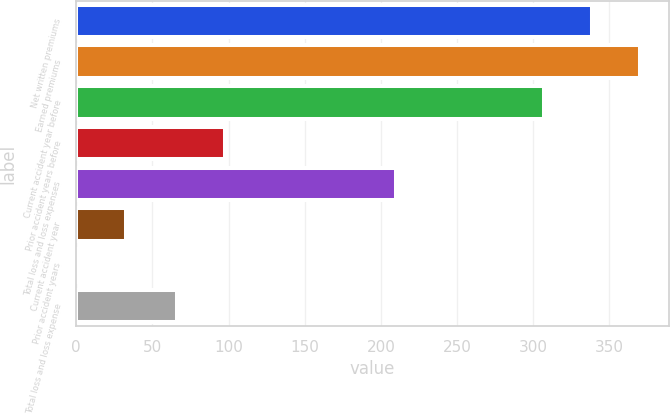Convert chart. <chart><loc_0><loc_0><loc_500><loc_500><bar_chart><fcel>Net written premiums<fcel>Earned premiums<fcel>Current accident year before<fcel>Prior accident years before<fcel>Total loss and loss expenses<fcel>Current accident year<fcel>Prior accident years<fcel>Total loss and loss expense<nl><fcel>338.69<fcel>370.38<fcel>307<fcel>97.79<fcel>210<fcel>32.81<fcel>1.12<fcel>66.1<nl></chart> 